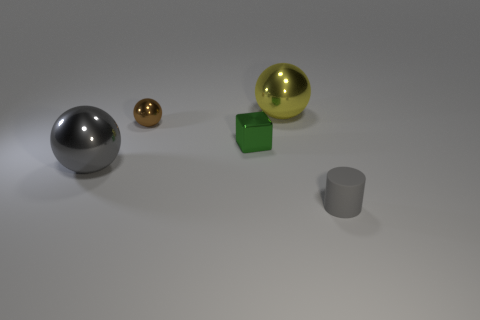What number of other objects are there of the same shape as the tiny green thing?
Offer a terse response. 0. Is the color of the sphere that is to the right of the small block the same as the tiny cube?
Your answer should be compact. No. How many other objects are the same size as the gray rubber cylinder?
Your answer should be compact. 2. Does the tiny gray cylinder have the same material as the brown thing?
Your response must be concise. No. The big shiny thing that is behind the large metal ball that is to the left of the yellow ball is what color?
Provide a succinct answer. Yellow. The gray object that is the same shape as the big yellow thing is what size?
Offer a very short reply. Large. Does the small matte cylinder have the same color as the tiny metal ball?
Your response must be concise. No. There is a small object in front of the metallic sphere that is on the left side of the brown shiny thing; what number of cubes are left of it?
Your answer should be compact. 1. Are there more small red blocks than tiny gray matte cylinders?
Your response must be concise. No. How many green cubes are there?
Provide a succinct answer. 1. 